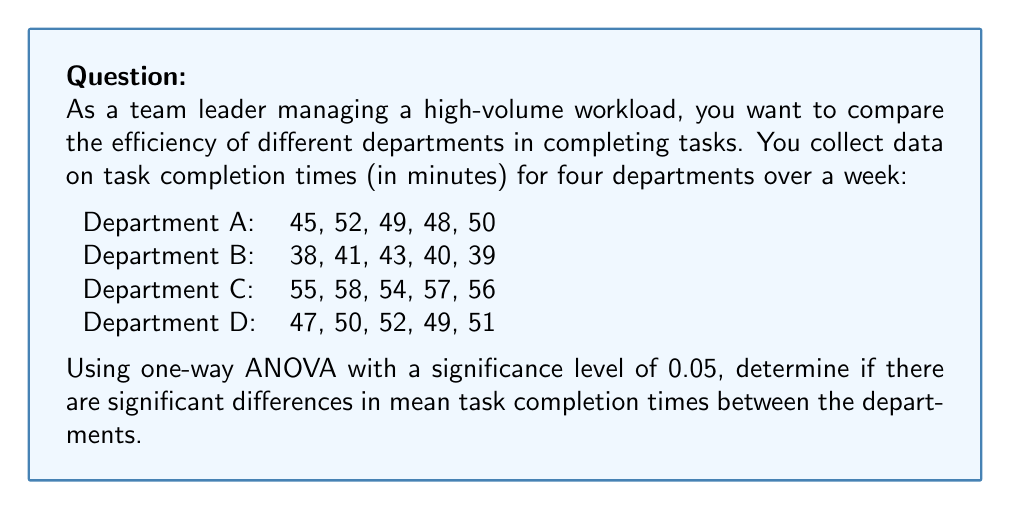Teach me how to tackle this problem. To solve this problem, we'll follow these steps:

1. State the null and alternative hypotheses
2. Calculate the sum of squares (SS) for between-groups and within-groups
3. Calculate the degrees of freedom (df)
4. Calculate the mean squares (MS)
5. Calculate the F-statistic
6. Determine the critical F-value
7. Make a decision based on the F-statistic and critical F-value

Step 1: Hypotheses
$H_0: \mu_A = \mu_B = \mu_C = \mu_D$ (all means are equal)
$H_a:$ At least one mean is different

Step 2: Calculate SS
First, calculate the grand mean:
$$\bar{X} = \frac{(45+52+...+51)}{20} = 48.7$$

Between-groups SS:
$$SS_B = 5[(48.8-48.7)^2 + (40.2-48.7)^2 + (56-48.7)^2 + (49.8-48.7)^2] = 741.8$$

Within-groups SS:
$$SS_W = [(45-48.8)^2 + (52-48.8)^2 + ...] = 114.8$$

Total SS:
$$SS_T = SS_B + SS_W = 741.8 + 114.8 = 856.6$$

Step 3: Degrees of freedom
$df_B = 4 - 1 = 3$
$df_W = 20 - 4 = 16$
$df_T = 20 - 1 = 19$

Step 4: Mean squares
$$MS_B = \frac{SS_B}{df_B} = \frac{741.8}{3} = 247.27$$
$$MS_W = \frac{SS_W}{df_W} = \frac{114.8}{16} = 7.18$$

Step 5: F-statistic
$$F = \frac{MS_B}{MS_W} = \frac{247.27}{7.18} = 34.44$$

Step 6: Critical F-value
For $\alpha = 0.05$, $df_B = 3$, and $df_W = 16$, the critical F-value is 3.24 (from F-distribution table).

Step 7: Decision
Since $F = 34.44 > F_{crit} = 3.24$, we reject the null hypothesis.
Answer: Reject the null hypothesis. There are significant differences in mean task completion times between the departments (F(3,16) = 34.44, p < 0.05). 